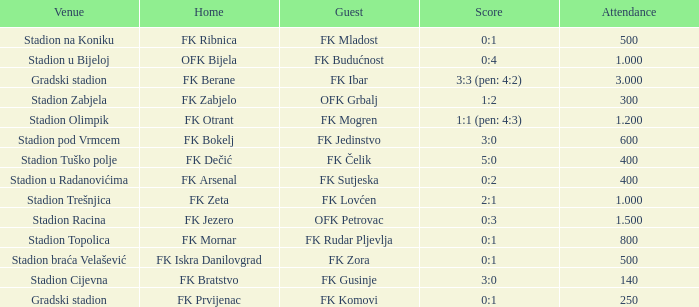What was the final score of the match in which fk bratstvo played as the host team? 3:0. 